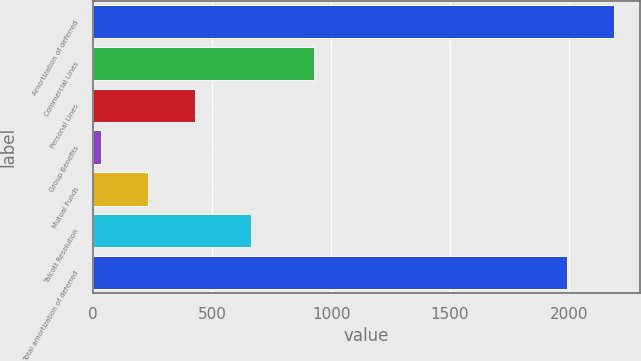Convert chart to OTSL. <chart><loc_0><loc_0><loc_500><loc_500><bar_chart><fcel>Amortization of deferred<fcel>Commercial Lines<fcel>Personal Lines<fcel>Group Benefits<fcel>Mutual Funds<fcel>Talcott Resolution<fcel>Total amortization of deferred<nl><fcel>2187.9<fcel>927<fcel>428.8<fcel>33<fcel>230.9<fcel>663<fcel>1990<nl></chart> 